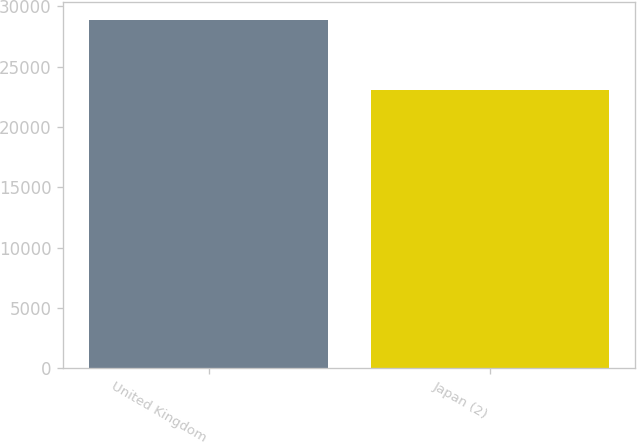<chart> <loc_0><loc_0><loc_500><loc_500><bar_chart><fcel>United Kingdom<fcel>Japan (2)<nl><fcel>28881<fcel>23046<nl></chart> 